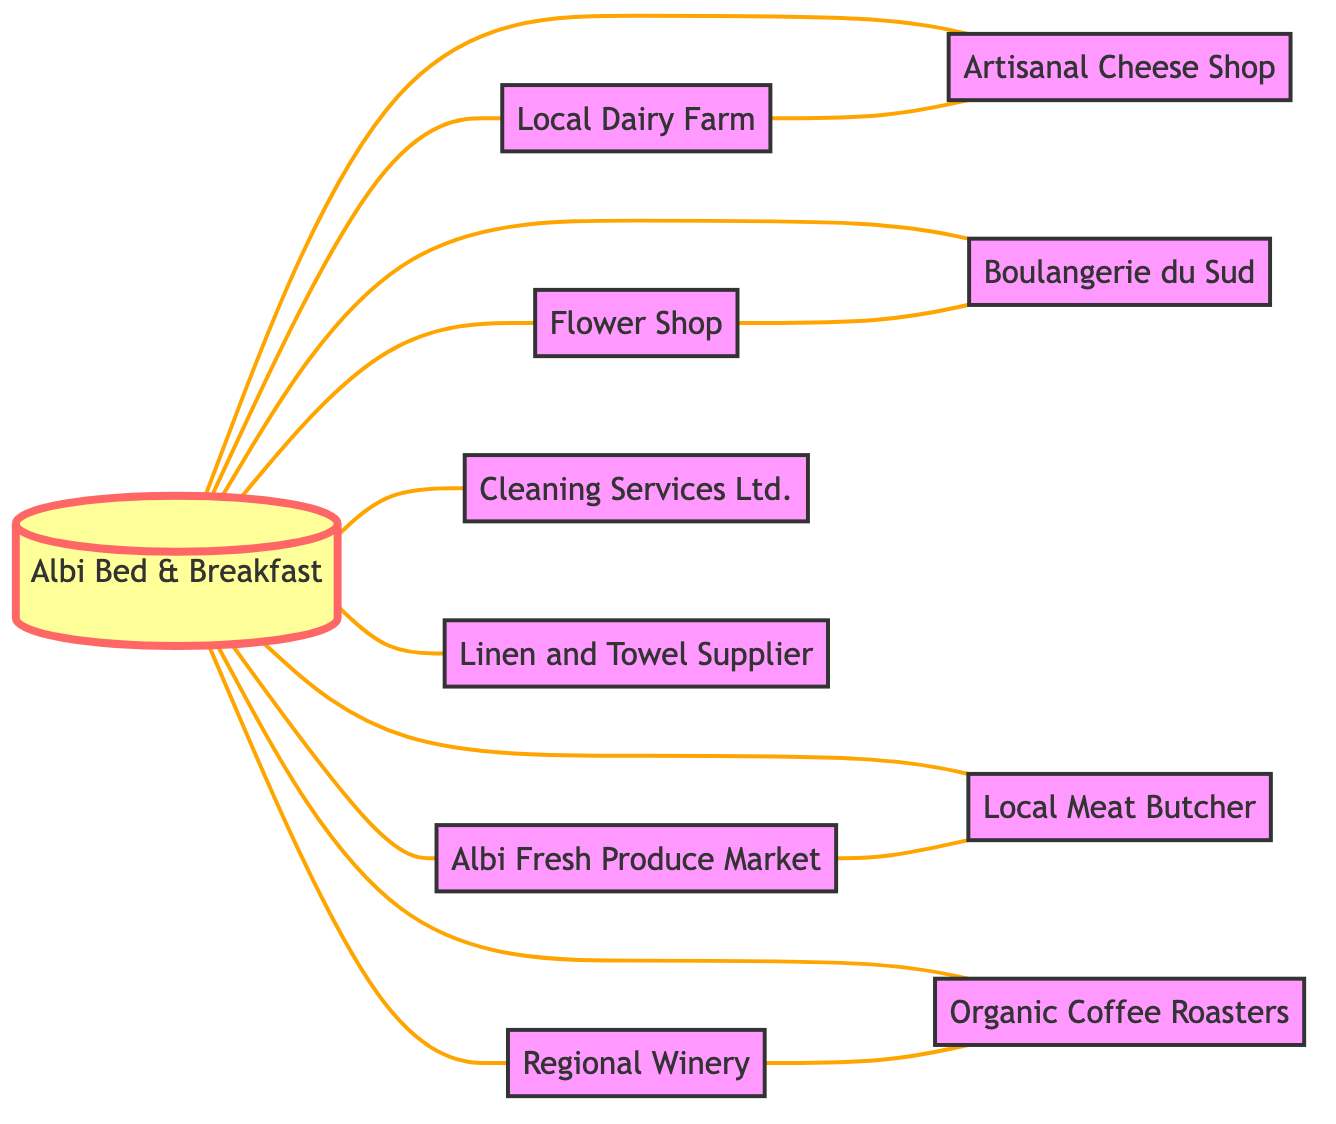What is the total number of nodes in the diagram? By counting the entries in the "nodes" section of the data provided, I find that there are 11 distinct nodes listed.
Answer: 11 Which local supplier is directly connected to the Albi Bed & Breakfast? Reviewing the edges, I can identify that the Albi Bed & Breakfast connects directly with multiple suppliers, including the Local Dairy Farm, Boulangerie du Sud, Albi Fresh Produce Market, Regional Winery, Artisanal Cheese Shop, Local Meat Butcher, Organic Coffee Roasters, Flower Shop, Cleaning Services Ltd., and Linen and Towel Supplier.
Answer: Local Dairy Farm, Boulangerie du Sud, Albi Fresh Produce Market, Regional Winery, Artisanal Cheese Shop, Local Meat Butcher, Organic Coffee Roasters, Flower Shop, Cleaning Services Ltd., Linen and Towel Supplier What is the relationship between the Local Dairy Farm and the Artisanal Cheese Shop? In examining the edges, I can see that the Local Dairy Farm is connected to the Artisanal Cheese Shop, indicating there is a direct relationship between the two suppliers.
Answer: Directly connected How many suppliers are linked to the Albi Fresh Produce Market? I see that Albi Fresh Produce Market is connected to two other nodes: Albi Bed & Breakfast and Local Meat Butcher, through the edges. So there are two suppliers that link with it.
Answer: 2 Which two suppliers are connected to both the Flower Shop and the Boulangerie du Sud? Analyzing the connections, I find that the only supplier linked with the Flower Shop is the Boulangerie du Sud, while there are no other common suppliers between them. Thus, it seems no other node shares a connection with both.
Answer: None How many edges are there in total in this diagram? By counting the entries in the "edges" section of the data provided, I can see that there are 13 connections established between suppliers in total.
Answer: 13 Which supplier has connections to both Organic Coffee Roasters and Regional Winery? After checking the connections, it is evident that there are no suppliers that connect both Organic Coffee Roasters and Regional Winery within the diagram's edges.
Answer: None What is the direct link between the Albi Fresh Produce Market and Local Meat Butcher? There is a direct edge connecting the Albi Fresh Produce Market to the Local Meat Butcher, indicating they have a direct relationship in the network.
Answer: Directly connected 